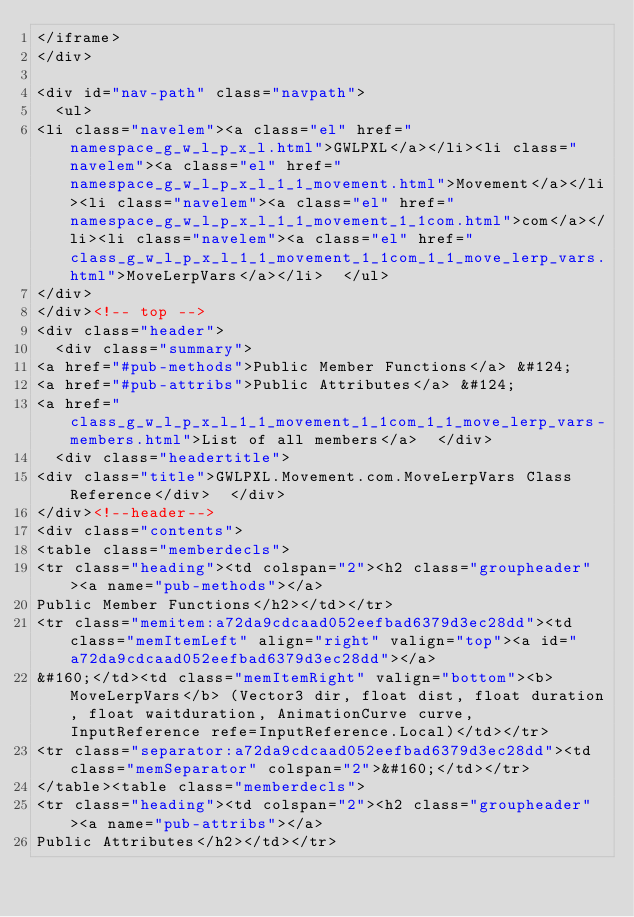<code> <loc_0><loc_0><loc_500><loc_500><_HTML_></iframe>
</div>

<div id="nav-path" class="navpath">
  <ul>
<li class="navelem"><a class="el" href="namespace_g_w_l_p_x_l.html">GWLPXL</a></li><li class="navelem"><a class="el" href="namespace_g_w_l_p_x_l_1_1_movement.html">Movement</a></li><li class="navelem"><a class="el" href="namespace_g_w_l_p_x_l_1_1_movement_1_1com.html">com</a></li><li class="navelem"><a class="el" href="class_g_w_l_p_x_l_1_1_movement_1_1com_1_1_move_lerp_vars.html">MoveLerpVars</a></li>  </ul>
</div>
</div><!-- top -->
<div class="header">
  <div class="summary">
<a href="#pub-methods">Public Member Functions</a> &#124;
<a href="#pub-attribs">Public Attributes</a> &#124;
<a href="class_g_w_l_p_x_l_1_1_movement_1_1com_1_1_move_lerp_vars-members.html">List of all members</a>  </div>
  <div class="headertitle">
<div class="title">GWLPXL.Movement.com.MoveLerpVars Class Reference</div>  </div>
</div><!--header-->
<div class="contents">
<table class="memberdecls">
<tr class="heading"><td colspan="2"><h2 class="groupheader"><a name="pub-methods"></a>
Public Member Functions</h2></td></tr>
<tr class="memitem:a72da9cdcaad052eefbad6379d3ec28dd"><td class="memItemLeft" align="right" valign="top"><a id="a72da9cdcaad052eefbad6379d3ec28dd"></a>
&#160;</td><td class="memItemRight" valign="bottom"><b>MoveLerpVars</b> (Vector3 dir, float dist, float duration, float waitduration, AnimationCurve curve, InputReference refe=InputReference.Local)</td></tr>
<tr class="separator:a72da9cdcaad052eefbad6379d3ec28dd"><td class="memSeparator" colspan="2">&#160;</td></tr>
</table><table class="memberdecls">
<tr class="heading"><td colspan="2"><h2 class="groupheader"><a name="pub-attribs"></a>
Public Attributes</h2></td></tr></code> 